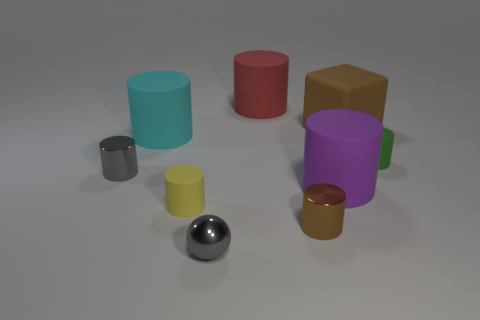Subtract all small gray cylinders. How many cylinders are left? 6 Subtract all brown cylinders. How many cylinders are left? 6 Subtract all gray cylinders. Subtract all cyan blocks. How many cylinders are left? 6 Subtract all cylinders. How many objects are left? 2 Add 2 green spheres. How many green spheres exist? 2 Subtract 0 brown spheres. How many objects are left? 9 Subtract all big matte things. Subtract all gray spheres. How many objects are left? 4 Add 3 gray shiny things. How many gray shiny things are left? 5 